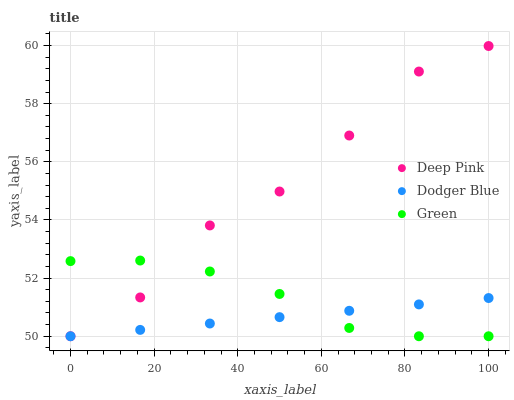Does Dodger Blue have the minimum area under the curve?
Answer yes or no. Yes. Does Deep Pink have the maximum area under the curve?
Answer yes or no. Yes. Does Deep Pink have the minimum area under the curve?
Answer yes or no. No. Does Dodger Blue have the maximum area under the curve?
Answer yes or no. No. Is Dodger Blue the smoothest?
Answer yes or no. Yes. Is Deep Pink the roughest?
Answer yes or no. Yes. Is Deep Pink the smoothest?
Answer yes or no. No. Is Dodger Blue the roughest?
Answer yes or no. No. Does Green have the lowest value?
Answer yes or no. Yes. Does Deep Pink have the highest value?
Answer yes or no. Yes. Does Dodger Blue have the highest value?
Answer yes or no. No. Does Green intersect Dodger Blue?
Answer yes or no. Yes. Is Green less than Dodger Blue?
Answer yes or no. No. Is Green greater than Dodger Blue?
Answer yes or no. No. 